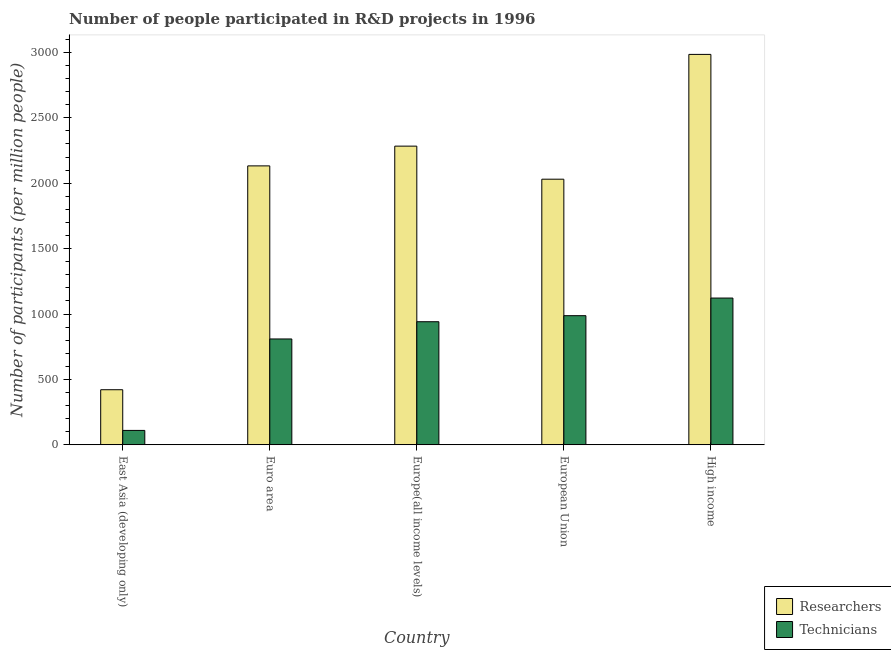How many different coloured bars are there?
Your answer should be very brief. 2. Are the number of bars per tick equal to the number of legend labels?
Make the answer very short. Yes. What is the label of the 5th group of bars from the left?
Your answer should be compact. High income. What is the number of researchers in Euro area?
Your answer should be compact. 2132.59. Across all countries, what is the maximum number of technicians?
Make the answer very short. 1121.96. Across all countries, what is the minimum number of researchers?
Ensure brevity in your answer.  421.02. In which country was the number of researchers minimum?
Keep it short and to the point. East Asia (developing only). What is the total number of researchers in the graph?
Make the answer very short. 9853.14. What is the difference between the number of researchers in Euro area and that in Europe(all income levels)?
Give a very brief answer. -151.05. What is the difference between the number of researchers in European Union and the number of technicians in High income?
Provide a short and direct response. 908.9. What is the average number of researchers per country?
Offer a very short reply. 1970.63. What is the difference between the number of technicians and number of researchers in Europe(all income levels)?
Make the answer very short. -1342.65. In how many countries, is the number of technicians greater than 200 ?
Provide a short and direct response. 4. What is the ratio of the number of researchers in East Asia (developing only) to that in High income?
Provide a succinct answer. 0.14. Is the number of technicians in Europe(all income levels) less than that in High income?
Give a very brief answer. Yes. Is the difference between the number of technicians in Euro area and High income greater than the difference between the number of researchers in Euro area and High income?
Offer a very short reply. Yes. What is the difference between the highest and the second highest number of researchers?
Make the answer very short. 701.41. What is the difference between the highest and the lowest number of technicians?
Give a very brief answer. 1012.06. Is the sum of the number of technicians in East Asia (developing only) and High income greater than the maximum number of researchers across all countries?
Make the answer very short. No. What does the 2nd bar from the left in East Asia (developing only) represents?
Offer a very short reply. Technicians. What does the 2nd bar from the right in High income represents?
Your answer should be compact. Researchers. How many countries are there in the graph?
Provide a short and direct response. 5. Does the graph contain grids?
Your answer should be very brief. No. How many legend labels are there?
Provide a succinct answer. 2. What is the title of the graph?
Offer a terse response. Number of people participated in R&D projects in 1996. Does "Under five" appear as one of the legend labels in the graph?
Make the answer very short. No. What is the label or title of the X-axis?
Offer a terse response. Country. What is the label or title of the Y-axis?
Your answer should be very brief. Number of participants (per million people). What is the Number of participants (per million people) of Researchers in East Asia (developing only)?
Your answer should be compact. 421.02. What is the Number of participants (per million people) in Technicians in East Asia (developing only)?
Make the answer very short. 109.91. What is the Number of participants (per million people) in Researchers in Euro area?
Your answer should be compact. 2132.59. What is the Number of participants (per million people) in Technicians in Euro area?
Provide a succinct answer. 809.18. What is the Number of participants (per million people) of Researchers in Europe(all income levels)?
Your response must be concise. 2283.63. What is the Number of participants (per million people) in Technicians in Europe(all income levels)?
Offer a terse response. 940.98. What is the Number of participants (per million people) of Researchers in European Union?
Ensure brevity in your answer.  2030.86. What is the Number of participants (per million people) of Technicians in European Union?
Make the answer very short. 987.23. What is the Number of participants (per million people) of Researchers in High income?
Keep it short and to the point. 2985.04. What is the Number of participants (per million people) in Technicians in High income?
Keep it short and to the point. 1121.96. Across all countries, what is the maximum Number of participants (per million people) in Researchers?
Provide a succinct answer. 2985.04. Across all countries, what is the maximum Number of participants (per million people) in Technicians?
Offer a terse response. 1121.96. Across all countries, what is the minimum Number of participants (per million people) in Researchers?
Offer a terse response. 421.02. Across all countries, what is the minimum Number of participants (per million people) in Technicians?
Keep it short and to the point. 109.91. What is the total Number of participants (per million people) of Researchers in the graph?
Ensure brevity in your answer.  9853.14. What is the total Number of participants (per million people) of Technicians in the graph?
Your answer should be very brief. 3969.27. What is the difference between the Number of participants (per million people) in Researchers in East Asia (developing only) and that in Euro area?
Your response must be concise. -1711.56. What is the difference between the Number of participants (per million people) in Technicians in East Asia (developing only) and that in Euro area?
Keep it short and to the point. -699.27. What is the difference between the Number of participants (per million people) in Researchers in East Asia (developing only) and that in Europe(all income levels)?
Make the answer very short. -1862.61. What is the difference between the Number of participants (per million people) in Technicians in East Asia (developing only) and that in Europe(all income levels)?
Offer a very short reply. -831.07. What is the difference between the Number of participants (per million people) in Researchers in East Asia (developing only) and that in European Union?
Make the answer very short. -1609.84. What is the difference between the Number of participants (per million people) of Technicians in East Asia (developing only) and that in European Union?
Ensure brevity in your answer.  -877.32. What is the difference between the Number of participants (per million people) in Researchers in East Asia (developing only) and that in High income?
Provide a succinct answer. -2564.01. What is the difference between the Number of participants (per million people) of Technicians in East Asia (developing only) and that in High income?
Keep it short and to the point. -1012.06. What is the difference between the Number of participants (per million people) of Researchers in Euro area and that in Europe(all income levels)?
Give a very brief answer. -151.05. What is the difference between the Number of participants (per million people) in Technicians in Euro area and that in Europe(all income levels)?
Offer a terse response. -131.8. What is the difference between the Number of participants (per million people) in Researchers in Euro area and that in European Union?
Make the answer very short. 101.72. What is the difference between the Number of participants (per million people) in Technicians in Euro area and that in European Union?
Your response must be concise. -178.05. What is the difference between the Number of participants (per million people) in Researchers in Euro area and that in High income?
Your answer should be very brief. -852.45. What is the difference between the Number of participants (per million people) in Technicians in Euro area and that in High income?
Ensure brevity in your answer.  -312.78. What is the difference between the Number of participants (per million people) in Researchers in Europe(all income levels) and that in European Union?
Offer a very short reply. 252.77. What is the difference between the Number of participants (per million people) of Technicians in Europe(all income levels) and that in European Union?
Provide a succinct answer. -46.25. What is the difference between the Number of participants (per million people) in Researchers in Europe(all income levels) and that in High income?
Give a very brief answer. -701.41. What is the difference between the Number of participants (per million people) in Technicians in Europe(all income levels) and that in High income?
Your answer should be very brief. -180.98. What is the difference between the Number of participants (per million people) of Researchers in European Union and that in High income?
Keep it short and to the point. -954.17. What is the difference between the Number of participants (per million people) in Technicians in European Union and that in High income?
Your answer should be compact. -134.73. What is the difference between the Number of participants (per million people) of Researchers in East Asia (developing only) and the Number of participants (per million people) of Technicians in Euro area?
Give a very brief answer. -388.16. What is the difference between the Number of participants (per million people) in Researchers in East Asia (developing only) and the Number of participants (per million people) in Technicians in Europe(all income levels)?
Provide a succinct answer. -519.96. What is the difference between the Number of participants (per million people) of Researchers in East Asia (developing only) and the Number of participants (per million people) of Technicians in European Union?
Provide a succinct answer. -566.21. What is the difference between the Number of participants (per million people) of Researchers in East Asia (developing only) and the Number of participants (per million people) of Technicians in High income?
Offer a terse response. -700.94. What is the difference between the Number of participants (per million people) of Researchers in Euro area and the Number of participants (per million people) of Technicians in Europe(all income levels)?
Ensure brevity in your answer.  1191.61. What is the difference between the Number of participants (per million people) in Researchers in Euro area and the Number of participants (per million people) in Technicians in European Union?
Your answer should be compact. 1145.36. What is the difference between the Number of participants (per million people) of Researchers in Euro area and the Number of participants (per million people) of Technicians in High income?
Offer a very short reply. 1010.62. What is the difference between the Number of participants (per million people) in Researchers in Europe(all income levels) and the Number of participants (per million people) in Technicians in European Union?
Give a very brief answer. 1296.4. What is the difference between the Number of participants (per million people) in Researchers in Europe(all income levels) and the Number of participants (per million people) in Technicians in High income?
Offer a very short reply. 1161.67. What is the difference between the Number of participants (per million people) of Researchers in European Union and the Number of participants (per million people) of Technicians in High income?
Offer a terse response. 908.9. What is the average Number of participants (per million people) of Researchers per country?
Give a very brief answer. 1970.63. What is the average Number of participants (per million people) of Technicians per country?
Offer a terse response. 793.85. What is the difference between the Number of participants (per million people) of Researchers and Number of participants (per million people) of Technicians in East Asia (developing only)?
Offer a terse response. 311.11. What is the difference between the Number of participants (per million people) in Researchers and Number of participants (per million people) in Technicians in Euro area?
Your answer should be compact. 1323.4. What is the difference between the Number of participants (per million people) of Researchers and Number of participants (per million people) of Technicians in Europe(all income levels)?
Your response must be concise. 1342.65. What is the difference between the Number of participants (per million people) in Researchers and Number of participants (per million people) in Technicians in European Union?
Keep it short and to the point. 1043.63. What is the difference between the Number of participants (per million people) of Researchers and Number of participants (per million people) of Technicians in High income?
Provide a succinct answer. 1863.07. What is the ratio of the Number of participants (per million people) of Researchers in East Asia (developing only) to that in Euro area?
Keep it short and to the point. 0.2. What is the ratio of the Number of participants (per million people) in Technicians in East Asia (developing only) to that in Euro area?
Make the answer very short. 0.14. What is the ratio of the Number of participants (per million people) of Researchers in East Asia (developing only) to that in Europe(all income levels)?
Offer a very short reply. 0.18. What is the ratio of the Number of participants (per million people) in Technicians in East Asia (developing only) to that in Europe(all income levels)?
Ensure brevity in your answer.  0.12. What is the ratio of the Number of participants (per million people) of Researchers in East Asia (developing only) to that in European Union?
Keep it short and to the point. 0.21. What is the ratio of the Number of participants (per million people) in Technicians in East Asia (developing only) to that in European Union?
Your answer should be very brief. 0.11. What is the ratio of the Number of participants (per million people) in Researchers in East Asia (developing only) to that in High income?
Offer a very short reply. 0.14. What is the ratio of the Number of participants (per million people) of Technicians in East Asia (developing only) to that in High income?
Give a very brief answer. 0.1. What is the ratio of the Number of participants (per million people) in Researchers in Euro area to that in Europe(all income levels)?
Keep it short and to the point. 0.93. What is the ratio of the Number of participants (per million people) of Technicians in Euro area to that in Europe(all income levels)?
Your answer should be compact. 0.86. What is the ratio of the Number of participants (per million people) in Researchers in Euro area to that in European Union?
Ensure brevity in your answer.  1.05. What is the ratio of the Number of participants (per million people) in Technicians in Euro area to that in European Union?
Your response must be concise. 0.82. What is the ratio of the Number of participants (per million people) in Researchers in Euro area to that in High income?
Your response must be concise. 0.71. What is the ratio of the Number of participants (per million people) of Technicians in Euro area to that in High income?
Offer a very short reply. 0.72. What is the ratio of the Number of participants (per million people) in Researchers in Europe(all income levels) to that in European Union?
Make the answer very short. 1.12. What is the ratio of the Number of participants (per million people) of Technicians in Europe(all income levels) to that in European Union?
Offer a terse response. 0.95. What is the ratio of the Number of participants (per million people) of Researchers in Europe(all income levels) to that in High income?
Provide a short and direct response. 0.77. What is the ratio of the Number of participants (per million people) in Technicians in Europe(all income levels) to that in High income?
Offer a terse response. 0.84. What is the ratio of the Number of participants (per million people) in Researchers in European Union to that in High income?
Offer a very short reply. 0.68. What is the ratio of the Number of participants (per million people) of Technicians in European Union to that in High income?
Provide a short and direct response. 0.88. What is the difference between the highest and the second highest Number of participants (per million people) of Researchers?
Provide a short and direct response. 701.41. What is the difference between the highest and the second highest Number of participants (per million people) of Technicians?
Make the answer very short. 134.73. What is the difference between the highest and the lowest Number of participants (per million people) of Researchers?
Keep it short and to the point. 2564.01. What is the difference between the highest and the lowest Number of participants (per million people) in Technicians?
Your answer should be very brief. 1012.06. 